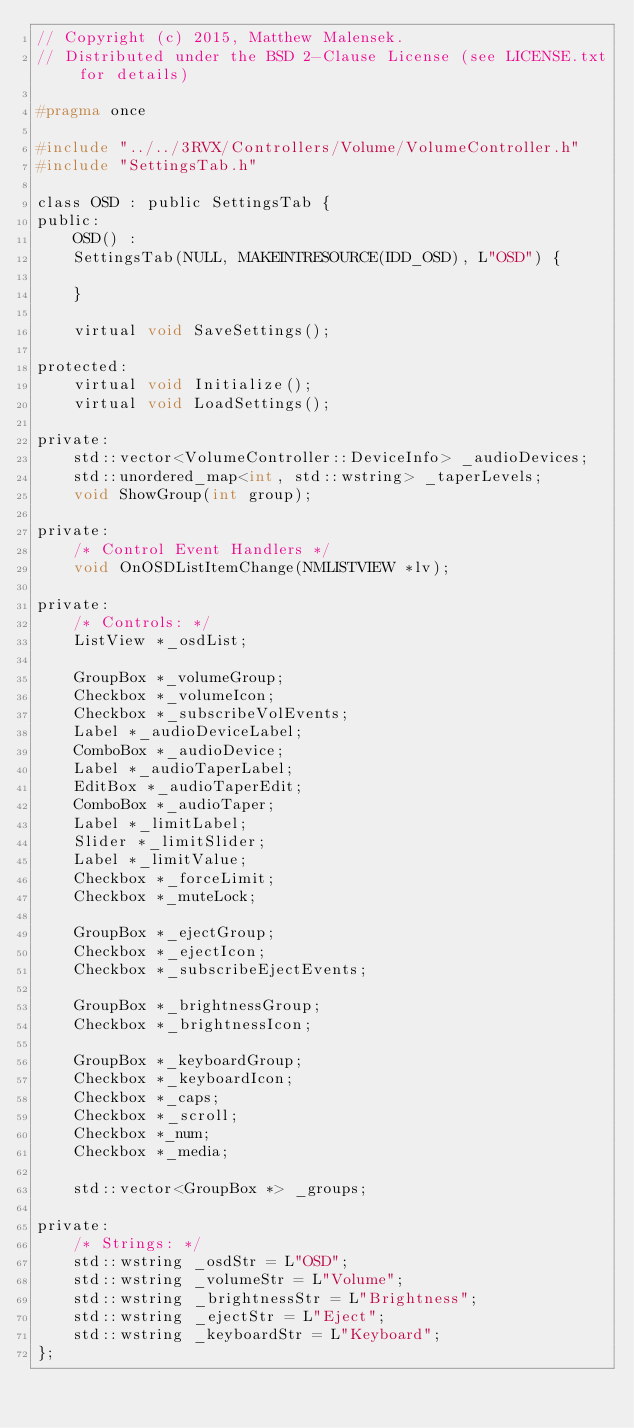Convert code to text. <code><loc_0><loc_0><loc_500><loc_500><_C_>// Copyright (c) 2015, Matthew Malensek.
// Distributed under the BSD 2-Clause License (see LICENSE.txt for details)

#pragma once

#include "../../3RVX/Controllers/Volume/VolumeController.h"
#include "SettingsTab.h"

class OSD : public SettingsTab {
public:
    OSD() :
    SettingsTab(NULL, MAKEINTRESOURCE(IDD_OSD), L"OSD") {

    }

    virtual void SaveSettings();

protected:
    virtual void Initialize();
    virtual void LoadSettings();

private:
    std::vector<VolumeController::DeviceInfo> _audioDevices;
    std::unordered_map<int, std::wstring> _taperLevels;
    void ShowGroup(int group);

private:
    /* Control Event Handlers */
    void OnOSDListItemChange(NMLISTVIEW *lv);

private:
    /* Controls: */
    ListView *_osdList;

    GroupBox *_volumeGroup;
    Checkbox *_volumeIcon;
    Checkbox *_subscribeVolEvents;
    Label *_audioDeviceLabel;
    ComboBox *_audioDevice;
    Label *_audioTaperLabel;
    EditBox *_audioTaperEdit;
    ComboBox *_audioTaper;
    Label *_limitLabel;
    Slider *_limitSlider;
    Label *_limitValue;
    Checkbox *_forceLimit;
    Checkbox *_muteLock;

    GroupBox *_ejectGroup;
    Checkbox *_ejectIcon;
    Checkbox *_subscribeEjectEvents;

    GroupBox *_brightnessGroup;
    Checkbox *_brightnessIcon;

    GroupBox *_keyboardGroup;
    Checkbox *_keyboardIcon;
    Checkbox *_caps;
    Checkbox *_scroll;
    Checkbox *_num;
    Checkbox *_media;

    std::vector<GroupBox *> _groups;

private:
    /* Strings: */
    std::wstring _osdStr = L"OSD";
    std::wstring _volumeStr = L"Volume";
    std::wstring _brightnessStr = L"Brightness";
    std::wstring _ejectStr = L"Eject";
    std::wstring _keyboardStr = L"Keyboard";
};
</code> 